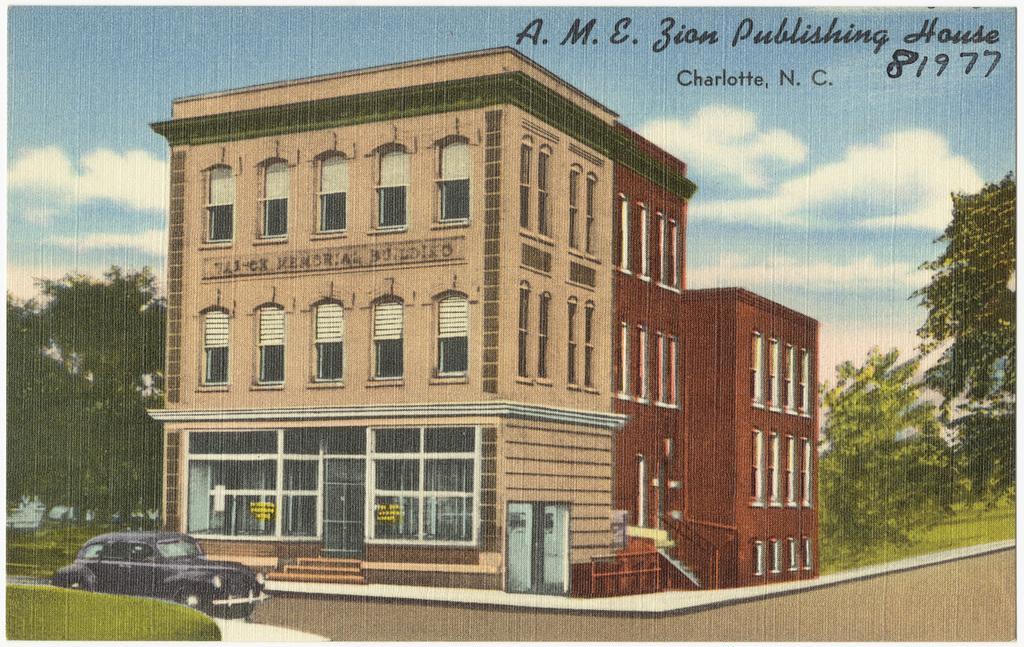Can you describe this image briefly? In the image we can see a painting, in the painting we can see building, the windows of the building and a vehicle. We can see trees, grass, text and cloudy pale blue sky. We can even see glass doors and windows. 